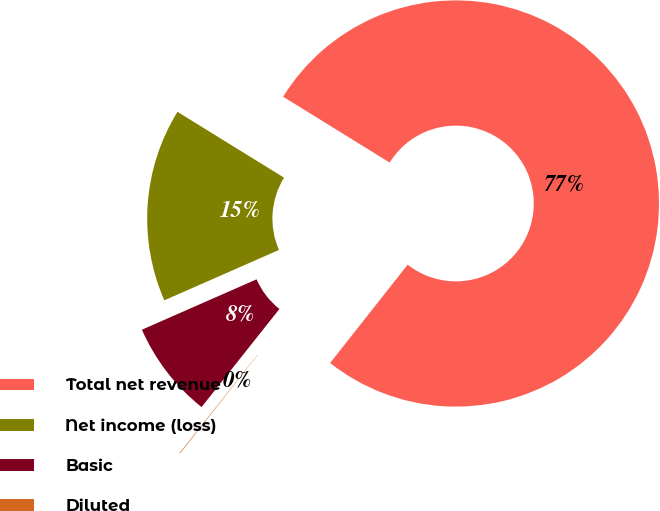<chart> <loc_0><loc_0><loc_500><loc_500><pie_chart><fcel>Total net revenue<fcel>Net income (loss)<fcel>Basic<fcel>Diluted<nl><fcel>76.82%<fcel>15.4%<fcel>7.73%<fcel>0.05%<nl></chart> 